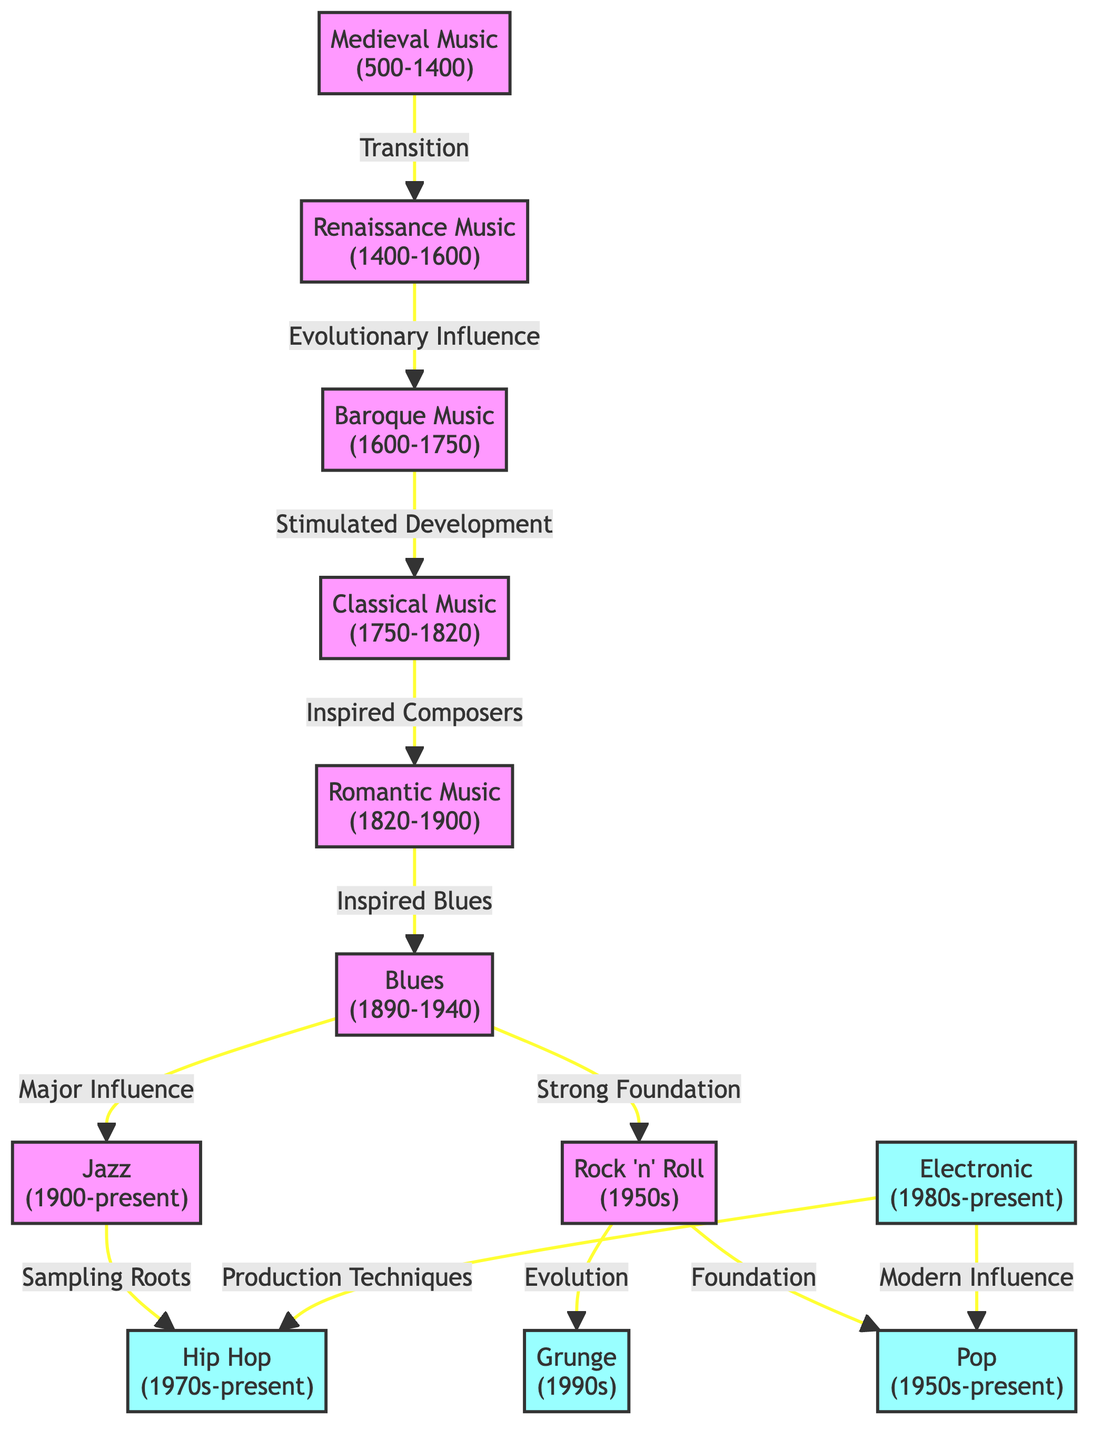What are the start and end years of Medieval Music? According to the diagram, Medieval Music spans from 500 to 1400. Therefore, the start year is 500 and the end year is 1400.
Answer: 500-1400 Which music genre evolved directly from Classical Music? The diagram indicates that Romantic Music evolved directly from Classical Music, as indicated by the directed arrow between these two nodes.
Answer: Romantic Music How many music genres precede Rock 'n' Roll? By examining the diagram, Rock 'n' Roll has four preceding genres—Blues, Classical Music, Baroque Music, and Renaissance Music. Each genre has a directed connection to Rock 'n' Roll.
Answer: 4 Which genre has both Blues and Rock 'n' Roll as foundational influences? The diagram shows that both Blues and Rock 'n' Roll have a directed influence on Jazz, as Blues provides a major influence and Rock 'n' Roll offers a strong foundation.
Answer: Jazz Which two music genres share a direct influence on Hip Hop? The diagram illustrates that both Jazz and Electronic genres influence Hip Hop, with directed arrows leading from both genres towards Hip Hop.
Answer: Jazz and Electronic What is the primary evolutionary influence from Medieval Music to Renaissance Music? The transition from Medieval Music to Renaissance Music is labeled as a simple "Transition" in the diagram. This indicates the type of connection between these two genres is designated as a transitionary one.
Answer: Transition How does the diagram describe the relationship between Grunge and Rock 'n' Roll? Grunge is shown in the diagram to have an evolutionary relationship with Rock 'n' Roll, with a directed arrow that indicates Grunge evolved from Rock 'n' Roll.
Answer: Evolution What production techniques influence Hip Hop according to the diagram? The diagram identifies "Production Techniques" from the Electronic genre as an influential factor regarding Hip Hop, showing that these techniques have a direct impact on the genre.
Answer: Production Techniques Which music genre is connected as a modern influence for Pop? The diagram indicates that Electronic music serves as a modern influence for Pop, as illustrated by the directed arrow leading towards Pop from Electronic.
Answer: Electronic 